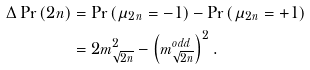Convert formula to latex. <formula><loc_0><loc_0><loc_500><loc_500>\Delta \Pr \left ( 2 n \right ) & = \Pr \left ( \mu _ { 2 n } = - 1 \right ) - \Pr \left ( \mu _ { 2 n } = + 1 \right ) \\ & = 2 m _ { \sqrt { 2 n } } ^ { 2 } - \left ( m _ { \sqrt { 2 n } } ^ { o d d } \right ) ^ { 2 } .</formula> 